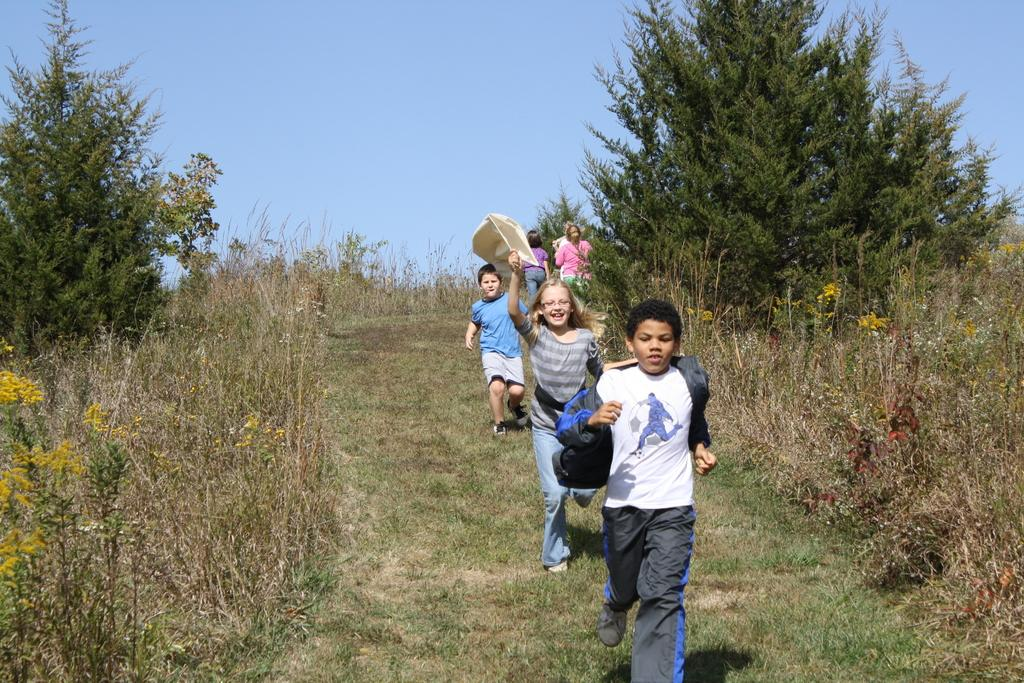What are the three kids in the image doing? The three kids in the image are running. What is the color of the ground they are running on? The ground they are running on is green. Can you describe the background of the image? There are other people behind the kids, and there are trees and plants on either side of the kids. How many times do the kids wish for something in the image? There is no indication in the image that the kids are wishing for anything, so it cannot be determined from the picture. 